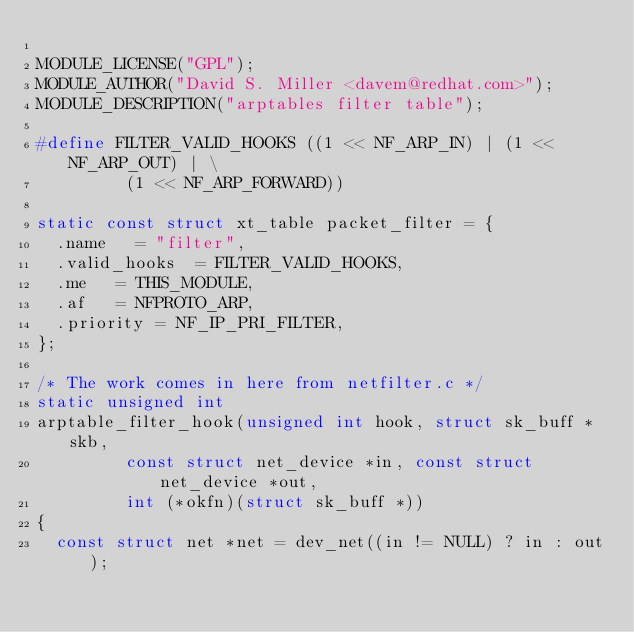Convert code to text. <code><loc_0><loc_0><loc_500><loc_500><_C_>
MODULE_LICENSE("GPL");
MODULE_AUTHOR("David S. Miller <davem@redhat.com>");
MODULE_DESCRIPTION("arptables filter table");

#define FILTER_VALID_HOOKS ((1 << NF_ARP_IN) | (1 << NF_ARP_OUT) | \
			   (1 << NF_ARP_FORWARD))

static const struct xt_table packet_filter = {
	.name		= "filter",
	.valid_hooks	= FILTER_VALID_HOOKS,
	.me		= THIS_MODULE,
	.af		= NFPROTO_ARP,
	.priority	= NF_IP_PRI_FILTER,
};

/* The work comes in here from netfilter.c */
static unsigned int
arptable_filter_hook(unsigned int hook, struct sk_buff *skb,
		     const struct net_device *in, const struct net_device *out,
		     int (*okfn)(struct sk_buff *))
{
	const struct net *net = dev_net((in != NULL) ? in : out);
</code> 